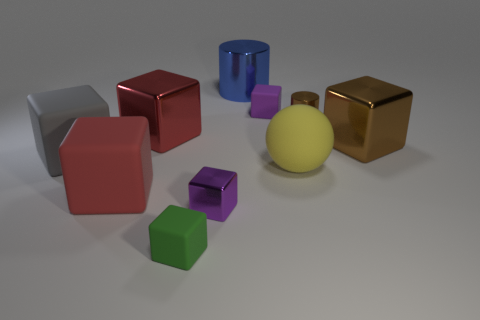The matte thing behind the big brown block is what color?
Ensure brevity in your answer.  Purple. The blue thing that is to the left of the small cube that is behind the red matte block is what shape?
Keep it short and to the point. Cylinder. Is the small shiny block the same color as the big metal cylinder?
Make the answer very short. No. How many cylinders are tiny brown objects or large blue metal objects?
Offer a terse response. 2. There is a block that is behind the brown block and on the left side of the small purple rubber block; what is its material?
Keep it short and to the point. Metal. What number of blue objects are on the left side of the small purple metal thing?
Make the answer very short. 0. Do the purple object that is behind the brown cylinder and the cylinder to the left of the large rubber sphere have the same material?
Provide a succinct answer. No. How many things are rubber things behind the gray matte cube or large shiny objects?
Make the answer very short. 4. Is the number of small green things right of the small shiny cylinder less than the number of small things that are to the left of the purple shiny thing?
Give a very brief answer. Yes. What number of other objects are the same size as the sphere?
Your response must be concise. 5. 